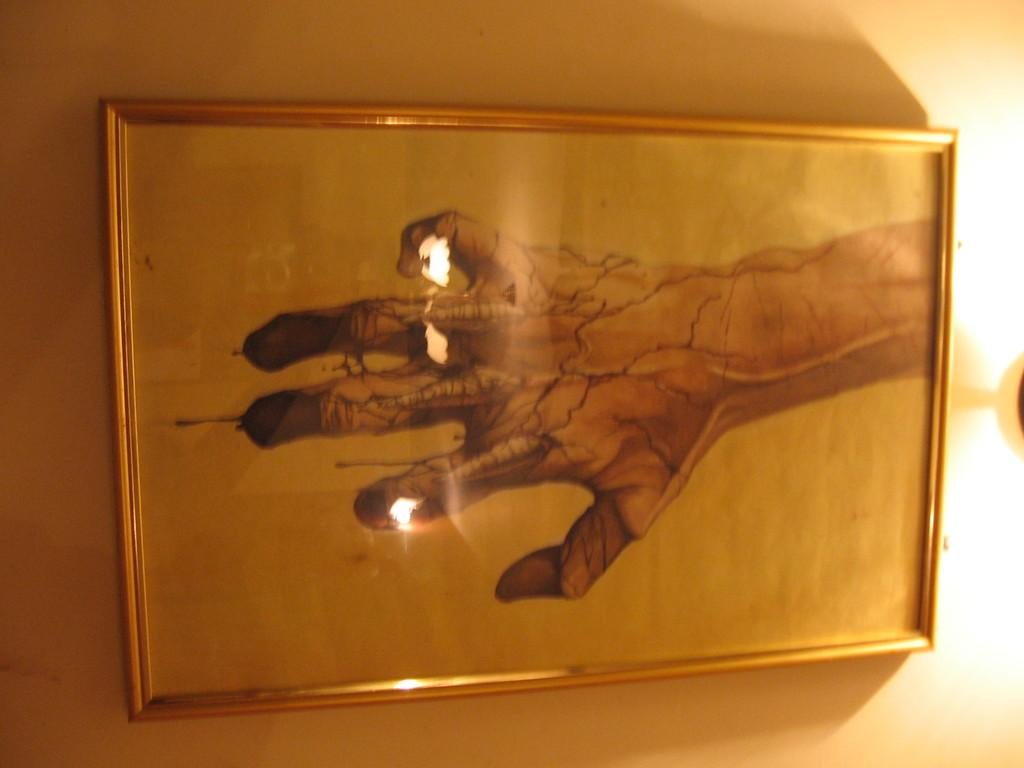What is hanging on the wall in the image? There is a frame on the wall in the image. What can be seen on the frame? The reflections of a few objects are visible on the frame. Where is the flag located in the image? There is no flag present in the image. What type of park can be seen in the image? There is no park present in the image. 